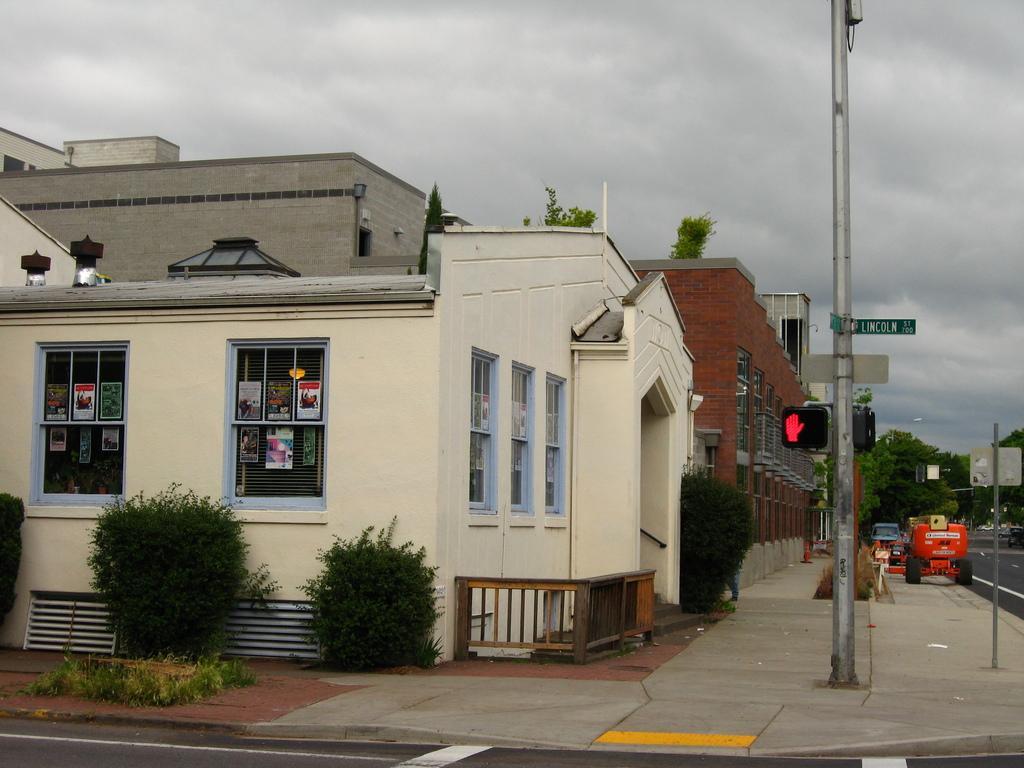Describe this image in one or two sentences. We can see plants,boards and traffic signals on poles,building,house,vehicles on the road and windows and we can see posters on this window. In the background we can see trees and sky. 